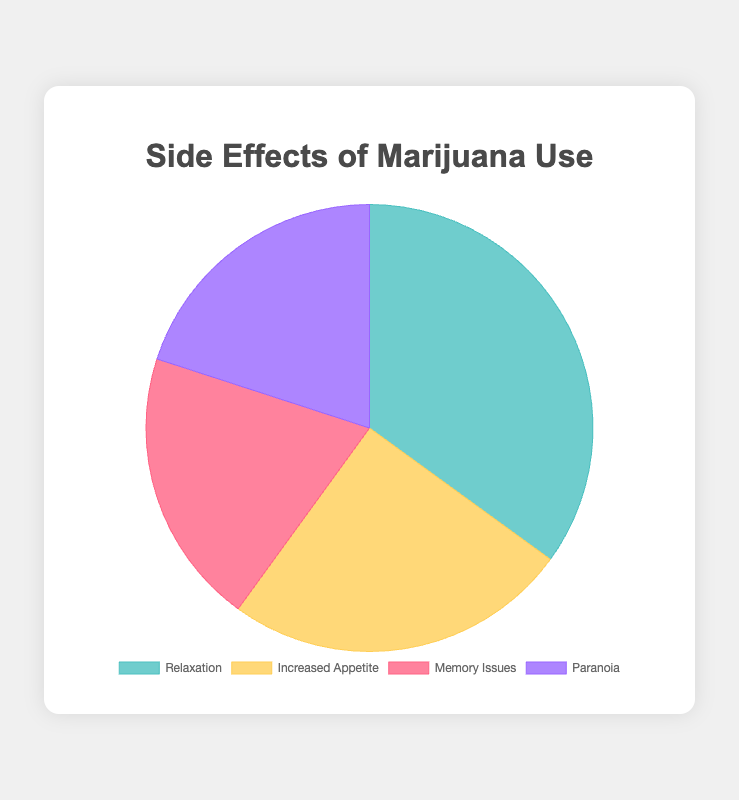What's the most common side effect of marijuana use? Look at the largest section of the pie chart, which represents the side effect with the highest percentage.
Answer: Relaxation What is the total percentage of people experiencing memory-related side effects? Sum the percentages of "Memory Issues" and "Paranoia." Memory Issues is 20% and Paranoia is 20%, so the total is 20 + 20 = 40%
Answer: 40% Which side effect has the smallest representation and how much is it? Compare the sizes of the pie chart sections to find the smallest one and look at its corresponding percentage. The smallest sections are "Memory Issues" and "Paranoia," each having 20%.
Answer: Memory Issues, 20% How much greater is the percentage of users experiencing relaxation compared to those experiencing increased appetite? Calculate the difference between the percentages for "Relaxation" and "Increased Appetite." Relaxation is 35% and Increased Appetite is 25%, so 35 - 25 = 10%
Answer: 10% Which two side effects have an equal percentage? Examine the pie chart for any side effects that occupy equal portions. "Memory Issues" and "Paranoia" each have a percentage of 20%.
Answer: Memory Issues and Paranoia What is the average percentage of side effects reported? Add up all the percentages for the side effects and divide by the number of side effects. (35 + 25 + 20 + 20) / 4 = 25%
Answer: 25% If you combine the effects of relaxation and increased appetite, what is the combined percentage? Sum the percentages for "Relaxation" and "Increased Appetite." Relaxation is 35% and Increased Appetite is 25%, so 35 + 25 = 60%
Answer: 60% Which section of the pie chart is represented by the color blue? The pie chart's legend often shows which color represents which category. In this case, the color blue represents "Relaxation."
Answer: Relaxation 